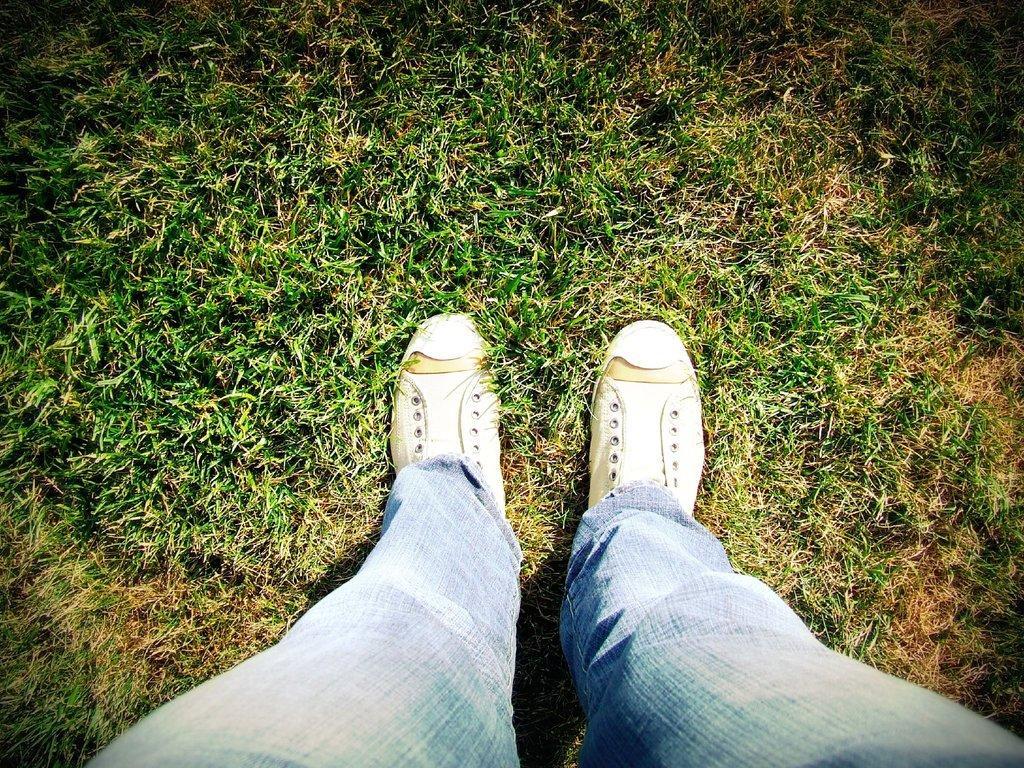Please provide a concise description of this image. In this image, I can see the legs of a person with shoes, which are on the grass. 